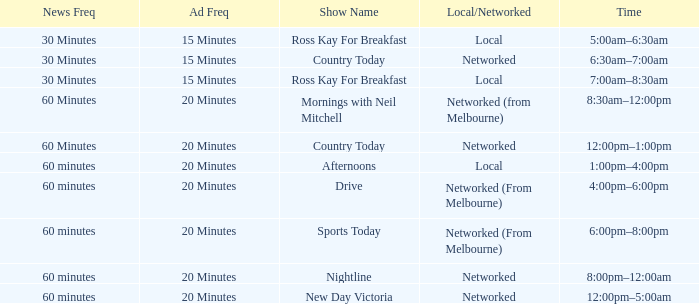What Ad Freq has a News Freq of 60 minutes, and a Local/Networked of local? 20 Minutes. 